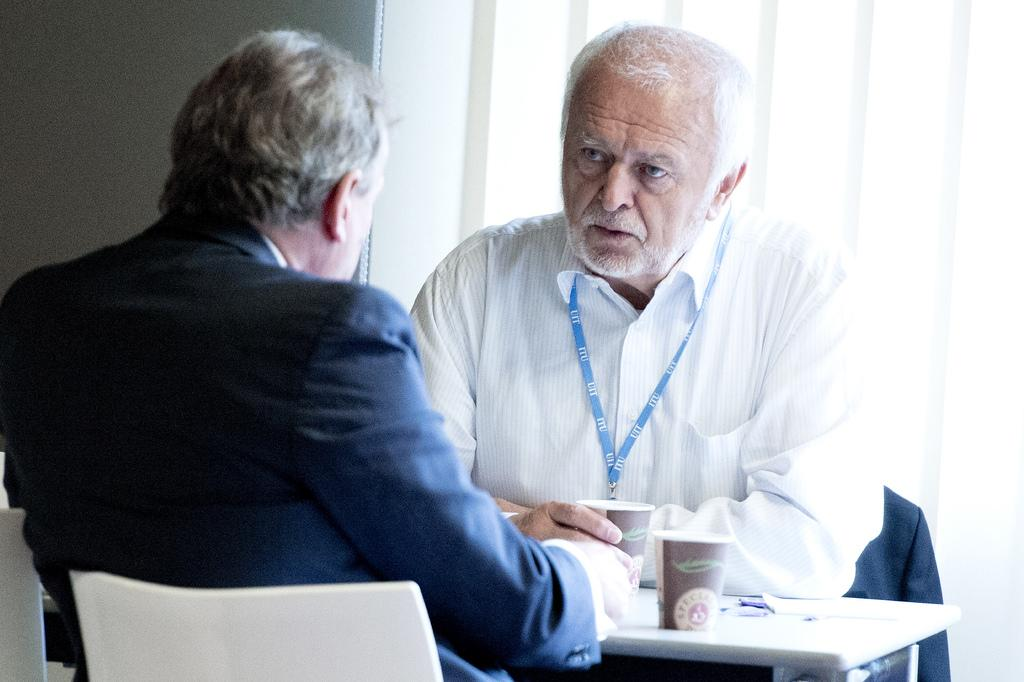What object can be seen in the bottom right corner of the image? There is a table in the bottom right corner of the image. What is placed on the table? There are cups on the table. How many people are sitting near the table? Two persons are sitting near the table. What is located behind the persons? There is a wall behind the persons. What type of letter is being written by the persons in the image? There is no indication in the image that the persons are writing a letter, so it cannot be determined from the picture. 